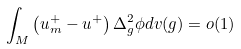<formula> <loc_0><loc_0><loc_500><loc_500>\int _ { M } \left ( u _ { m } ^ { + } - u ^ { + } \right ) \Delta _ { g } ^ { 2 } \phi d v ( g ) = o ( 1 )</formula> 